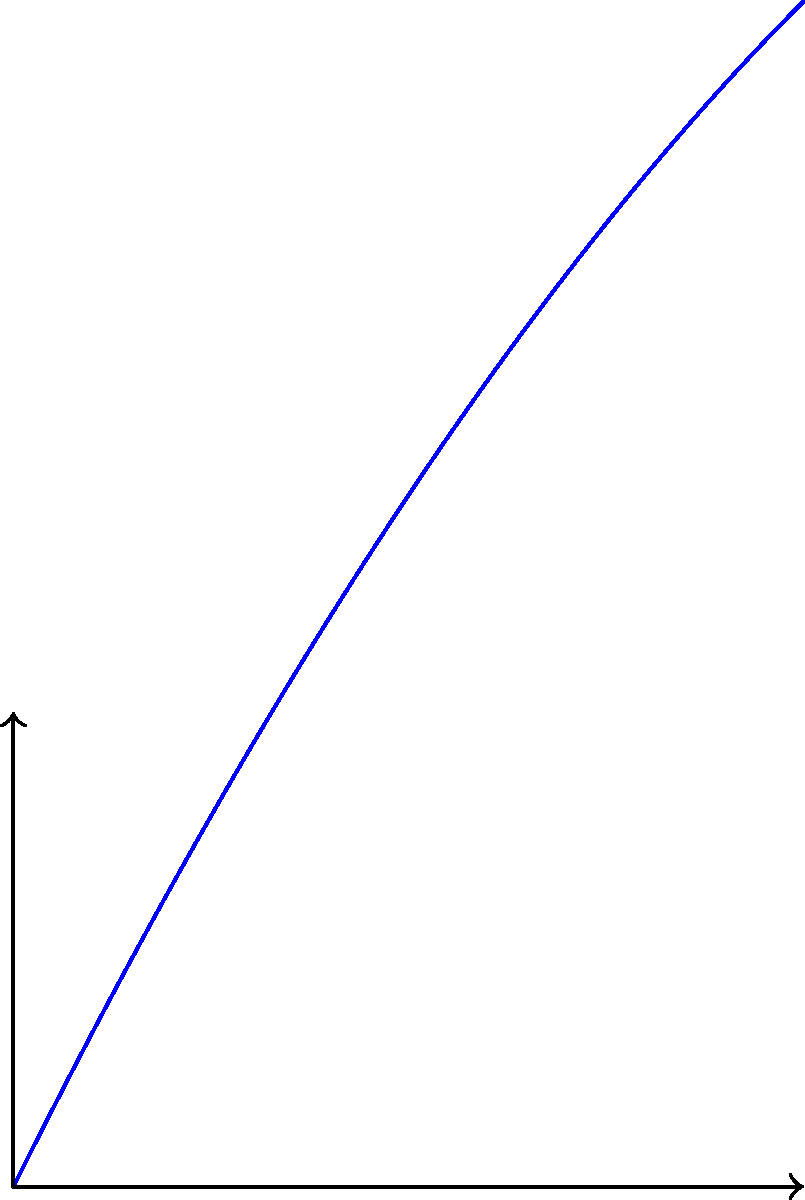A World War II fighter plane is flying at a constant altitude of 3000 feet and releases a bomb. The bomb's trajectory can be modeled by the function $h(x) = -0.05x^2 + 2x + 3$, where $h$ is the height in thousands of feet and $x$ is the horizontal distance in thousands of feet. At what horizontal distance from the release point does the bomb hit the ground? To find the horizontal distance at which the bomb hits the ground, we need to solve the equation $h(x) = 0$. This is because the bomb hits the ground when its height is zero.

1) Set up the equation:
   $0 = -0.05x^2 + 2x + 3$

2) Rearrange to standard quadratic form:
   $0.05x^2 - 2x - 3 = 0$

3) Use the quadratic formula: $x = \frac{-b \pm \sqrt{b^2 - 4ac}}{2a}$
   Where $a = 0.05$, $b = -2$, and $c = -3$

4) Substitute into the quadratic formula:
   $x = \frac{2 \pm \sqrt{(-2)^2 - 4(0.05)(-3)}}{2(0.05)}$

5) Simplify:
   $x = \frac{2 \pm \sqrt{4 + 0.6}}{0.1} = \frac{2 \pm \sqrt{4.6}}{0.1}$

6) Calculate:
   $x \approx 8$ or $x \approx -38$

7) Since negative distance doesn't make sense in this context, we take the positive solution.

Therefore, the bomb hits the ground approximately 8,000 feet (8 thousand feet) from the release point.
Answer: 8,000 feet 